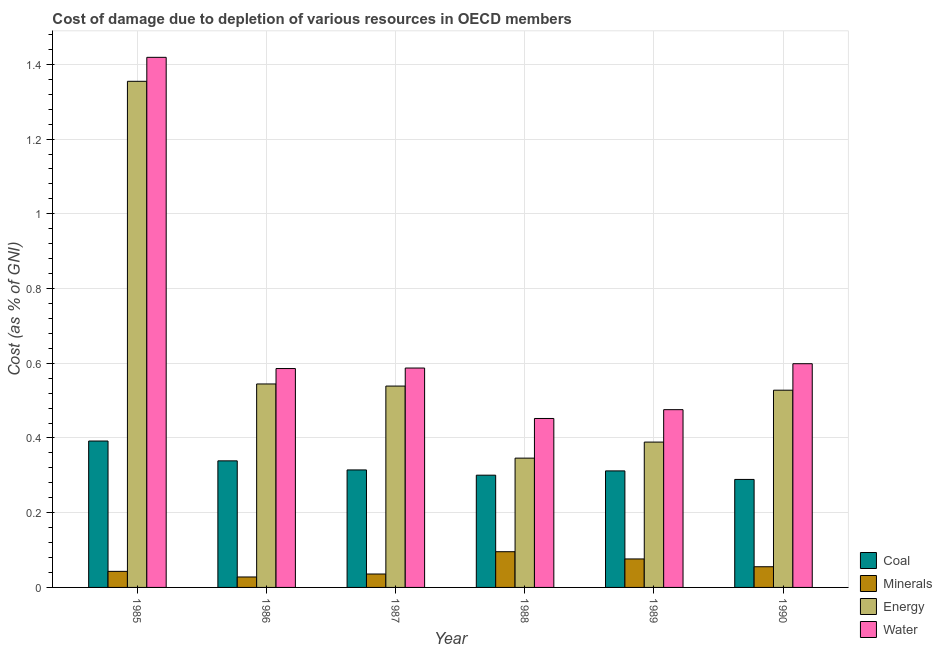How many groups of bars are there?
Offer a very short reply. 6. Are the number of bars per tick equal to the number of legend labels?
Offer a terse response. Yes. How many bars are there on the 4th tick from the right?
Keep it short and to the point. 4. What is the label of the 5th group of bars from the left?
Give a very brief answer. 1989. What is the cost of damage due to depletion of water in 1986?
Give a very brief answer. 0.59. Across all years, what is the maximum cost of damage due to depletion of energy?
Keep it short and to the point. 1.35. Across all years, what is the minimum cost of damage due to depletion of minerals?
Offer a terse response. 0.03. What is the total cost of damage due to depletion of water in the graph?
Your response must be concise. 4.12. What is the difference between the cost of damage due to depletion of minerals in 1985 and that in 1990?
Provide a short and direct response. -0.01. What is the difference between the cost of damage due to depletion of water in 1988 and the cost of damage due to depletion of energy in 1986?
Your answer should be compact. -0.13. What is the average cost of damage due to depletion of coal per year?
Your response must be concise. 0.32. What is the ratio of the cost of damage due to depletion of coal in 1985 to that in 1987?
Make the answer very short. 1.25. Is the cost of damage due to depletion of water in 1987 less than that in 1990?
Provide a succinct answer. Yes. What is the difference between the highest and the second highest cost of damage due to depletion of minerals?
Make the answer very short. 0.02. What is the difference between the highest and the lowest cost of damage due to depletion of water?
Provide a succinct answer. 0.97. In how many years, is the cost of damage due to depletion of minerals greater than the average cost of damage due to depletion of minerals taken over all years?
Provide a short and direct response. 2. Is it the case that in every year, the sum of the cost of damage due to depletion of water and cost of damage due to depletion of minerals is greater than the sum of cost of damage due to depletion of coal and cost of damage due to depletion of energy?
Ensure brevity in your answer.  Yes. What does the 3rd bar from the left in 1987 represents?
Offer a very short reply. Energy. What does the 3rd bar from the right in 1989 represents?
Provide a short and direct response. Minerals. Is it the case that in every year, the sum of the cost of damage due to depletion of coal and cost of damage due to depletion of minerals is greater than the cost of damage due to depletion of energy?
Provide a succinct answer. No. How many bars are there?
Give a very brief answer. 24. Are all the bars in the graph horizontal?
Offer a terse response. No. Does the graph contain any zero values?
Your response must be concise. No. How many legend labels are there?
Offer a terse response. 4. How are the legend labels stacked?
Offer a very short reply. Vertical. What is the title of the graph?
Ensure brevity in your answer.  Cost of damage due to depletion of various resources in OECD members . Does "SF6 gas" appear as one of the legend labels in the graph?
Offer a very short reply. No. What is the label or title of the X-axis?
Your answer should be very brief. Year. What is the label or title of the Y-axis?
Your response must be concise. Cost (as % of GNI). What is the Cost (as % of GNI) of Coal in 1985?
Your answer should be compact. 0.39. What is the Cost (as % of GNI) in Minerals in 1985?
Your response must be concise. 0.04. What is the Cost (as % of GNI) of Energy in 1985?
Make the answer very short. 1.35. What is the Cost (as % of GNI) in Water in 1985?
Give a very brief answer. 1.42. What is the Cost (as % of GNI) of Coal in 1986?
Ensure brevity in your answer.  0.34. What is the Cost (as % of GNI) in Minerals in 1986?
Offer a very short reply. 0.03. What is the Cost (as % of GNI) in Energy in 1986?
Your answer should be compact. 0.54. What is the Cost (as % of GNI) of Water in 1986?
Ensure brevity in your answer.  0.59. What is the Cost (as % of GNI) of Coal in 1987?
Provide a succinct answer. 0.31. What is the Cost (as % of GNI) of Minerals in 1987?
Your answer should be compact. 0.04. What is the Cost (as % of GNI) in Energy in 1987?
Give a very brief answer. 0.54. What is the Cost (as % of GNI) of Water in 1987?
Ensure brevity in your answer.  0.59. What is the Cost (as % of GNI) in Coal in 1988?
Your answer should be very brief. 0.3. What is the Cost (as % of GNI) in Minerals in 1988?
Offer a very short reply. 0.1. What is the Cost (as % of GNI) in Energy in 1988?
Make the answer very short. 0.35. What is the Cost (as % of GNI) in Water in 1988?
Make the answer very short. 0.45. What is the Cost (as % of GNI) in Coal in 1989?
Your answer should be compact. 0.31. What is the Cost (as % of GNI) in Minerals in 1989?
Provide a short and direct response. 0.08. What is the Cost (as % of GNI) of Energy in 1989?
Provide a succinct answer. 0.39. What is the Cost (as % of GNI) in Water in 1989?
Ensure brevity in your answer.  0.48. What is the Cost (as % of GNI) in Coal in 1990?
Provide a short and direct response. 0.29. What is the Cost (as % of GNI) of Minerals in 1990?
Offer a terse response. 0.06. What is the Cost (as % of GNI) of Energy in 1990?
Your answer should be very brief. 0.53. What is the Cost (as % of GNI) in Water in 1990?
Offer a very short reply. 0.6. Across all years, what is the maximum Cost (as % of GNI) in Coal?
Provide a succinct answer. 0.39. Across all years, what is the maximum Cost (as % of GNI) of Minerals?
Offer a very short reply. 0.1. Across all years, what is the maximum Cost (as % of GNI) in Energy?
Your answer should be very brief. 1.35. Across all years, what is the maximum Cost (as % of GNI) in Water?
Provide a succinct answer. 1.42. Across all years, what is the minimum Cost (as % of GNI) of Coal?
Your answer should be compact. 0.29. Across all years, what is the minimum Cost (as % of GNI) in Minerals?
Offer a very short reply. 0.03. Across all years, what is the minimum Cost (as % of GNI) of Energy?
Ensure brevity in your answer.  0.35. Across all years, what is the minimum Cost (as % of GNI) of Water?
Keep it short and to the point. 0.45. What is the total Cost (as % of GNI) in Coal in the graph?
Give a very brief answer. 1.95. What is the total Cost (as % of GNI) of Minerals in the graph?
Ensure brevity in your answer.  0.33. What is the total Cost (as % of GNI) of Energy in the graph?
Provide a short and direct response. 3.7. What is the total Cost (as % of GNI) of Water in the graph?
Provide a succinct answer. 4.12. What is the difference between the Cost (as % of GNI) in Coal in 1985 and that in 1986?
Give a very brief answer. 0.05. What is the difference between the Cost (as % of GNI) of Minerals in 1985 and that in 1986?
Ensure brevity in your answer.  0.01. What is the difference between the Cost (as % of GNI) of Energy in 1985 and that in 1986?
Give a very brief answer. 0.81. What is the difference between the Cost (as % of GNI) in Water in 1985 and that in 1986?
Offer a very short reply. 0.83. What is the difference between the Cost (as % of GNI) in Coal in 1985 and that in 1987?
Offer a very short reply. 0.08. What is the difference between the Cost (as % of GNI) of Minerals in 1985 and that in 1987?
Your answer should be very brief. 0.01. What is the difference between the Cost (as % of GNI) in Energy in 1985 and that in 1987?
Provide a succinct answer. 0.82. What is the difference between the Cost (as % of GNI) in Water in 1985 and that in 1987?
Give a very brief answer. 0.83. What is the difference between the Cost (as % of GNI) in Coal in 1985 and that in 1988?
Ensure brevity in your answer.  0.09. What is the difference between the Cost (as % of GNI) of Minerals in 1985 and that in 1988?
Offer a very short reply. -0.05. What is the difference between the Cost (as % of GNI) of Energy in 1985 and that in 1988?
Your answer should be compact. 1.01. What is the difference between the Cost (as % of GNI) of Water in 1985 and that in 1988?
Make the answer very short. 0.97. What is the difference between the Cost (as % of GNI) in Minerals in 1985 and that in 1989?
Offer a very short reply. -0.03. What is the difference between the Cost (as % of GNI) of Energy in 1985 and that in 1989?
Give a very brief answer. 0.97. What is the difference between the Cost (as % of GNI) in Water in 1985 and that in 1989?
Offer a very short reply. 0.94. What is the difference between the Cost (as % of GNI) of Coal in 1985 and that in 1990?
Your response must be concise. 0.1. What is the difference between the Cost (as % of GNI) of Minerals in 1985 and that in 1990?
Provide a short and direct response. -0.01. What is the difference between the Cost (as % of GNI) in Energy in 1985 and that in 1990?
Ensure brevity in your answer.  0.83. What is the difference between the Cost (as % of GNI) of Water in 1985 and that in 1990?
Ensure brevity in your answer.  0.82. What is the difference between the Cost (as % of GNI) of Coal in 1986 and that in 1987?
Your response must be concise. 0.02. What is the difference between the Cost (as % of GNI) of Minerals in 1986 and that in 1987?
Your response must be concise. -0.01. What is the difference between the Cost (as % of GNI) of Energy in 1986 and that in 1987?
Give a very brief answer. 0.01. What is the difference between the Cost (as % of GNI) of Water in 1986 and that in 1987?
Give a very brief answer. -0. What is the difference between the Cost (as % of GNI) in Coal in 1986 and that in 1988?
Provide a short and direct response. 0.04. What is the difference between the Cost (as % of GNI) of Minerals in 1986 and that in 1988?
Make the answer very short. -0.07. What is the difference between the Cost (as % of GNI) of Energy in 1986 and that in 1988?
Offer a very short reply. 0.2. What is the difference between the Cost (as % of GNI) in Water in 1986 and that in 1988?
Provide a short and direct response. 0.13. What is the difference between the Cost (as % of GNI) in Coal in 1986 and that in 1989?
Provide a succinct answer. 0.03. What is the difference between the Cost (as % of GNI) of Minerals in 1986 and that in 1989?
Your response must be concise. -0.05. What is the difference between the Cost (as % of GNI) in Energy in 1986 and that in 1989?
Provide a succinct answer. 0.16. What is the difference between the Cost (as % of GNI) in Water in 1986 and that in 1989?
Offer a terse response. 0.11. What is the difference between the Cost (as % of GNI) of Coal in 1986 and that in 1990?
Your answer should be compact. 0.05. What is the difference between the Cost (as % of GNI) of Minerals in 1986 and that in 1990?
Ensure brevity in your answer.  -0.03. What is the difference between the Cost (as % of GNI) of Energy in 1986 and that in 1990?
Your answer should be very brief. 0.02. What is the difference between the Cost (as % of GNI) of Water in 1986 and that in 1990?
Your response must be concise. -0.01. What is the difference between the Cost (as % of GNI) in Coal in 1987 and that in 1988?
Your response must be concise. 0.01. What is the difference between the Cost (as % of GNI) of Minerals in 1987 and that in 1988?
Provide a succinct answer. -0.06. What is the difference between the Cost (as % of GNI) of Energy in 1987 and that in 1988?
Your answer should be compact. 0.19. What is the difference between the Cost (as % of GNI) in Water in 1987 and that in 1988?
Your answer should be compact. 0.14. What is the difference between the Cost (as % of GNI) of Coal in 1987 and that in 1989?
Provide a succinct answer. 0. What is the difference between the Cost (as % of GNI) of Minerals in 1987 and that in 1989?
Keep it short and to the point. -0.04. What is the difference between the Cost (as % of GNI) in Energy in 1987 and that in 1989?
Make the answer very short. 0.15. What is the difference between the Cost (as % of GNI) of Water in 1987 and that in 1989?
Ensure brevity in your answer.  0.11. What is the difference between the Cost (as % of GNI) in Coal in 1987 and that in 1990?
Ensure brevity in your answer.  0.03. What is the difference between the Cost (as % of GNI) of Minerals in 1987 and that in 1990?
Provide a succinct answer. -0.02. What is the difference between the Cost (as % of GNI) of Energy in 1987 and that in 1990?
Your answer should be very brief. 0.01. What is the difference between the Cost (as % of GNI) of Water in 1987 and that in 1990?
Your response must be concise. -0.01. What is the difference between the Cost (as % of GNI) in Coal in 1988 and that in 1989?
Your answer should be compact. -0.01. What is the difference between the Cost (as % of GNI) of Minerals in 1988 and that in 1989?
Your answer should be very brief. 0.02. What is the difference between the Cost (as % of GNI) in Energy in 1988 and that in 1989?
Keep it short and to the point. -0.04. What is the difference between the Cost (as % of GNI) in Water in 1988 and that in 1989?
Make the answer very short. -0.02. What is the difference between the Cost (as % of GNI) of Coal in 1988 and that in 1990?
Make the answer very short. 0.01. What is the difference between the Cost (as % of GNI) of Minerals in 1988 and that in 1990?
Your answer should be very brief. 0.04. What is the difference between the Cost (as % of GNI) in Energy in 1988 and that in 1990?
Provide a succinct answer. -0.18. What is the difference between the Cost (as % of GNI) of Water in 1988 and that in 1990?
Keep it short and to the point. -0.15. What is the difference between the Cost (as % of GNI) of Coal in 1989 and that in 1990?
Make the answer very short. 0.02. What is the difference between the Cost (as % of GNI) in Minerals in 1989 and that in 1990?
Ensure brevity in your answer.  0.02. What is the difference between the Cost (as % of GNI) in Energy in 1989 and that in 1990?
Keep it short and to the point. -0.14. What is the difference between the Cost (as % of GNI) in Water in 1989 and that in 1990?
Offer a terse response. -0.12. What is the difference between the Cost (as % of GNI) in Coal in 1985 and the Cost (as % of GNI) in Minerals in 1986?
Give a very brief answer. 0.36. What is the difference between the Cost (as % of GNI) in Coal in 1985 and the Cost (as % of GNI) in Energy in 1986?
Provide a short and direct response. -0.15. What is the difference between the Cost (as % of GNI) in Coal in 1985 and the Cost (as % of GNI) in Water in 1986?
Offer a terse response. -0.19. What is the difference between the Cost (as % of GNI) in Minerals in 1985 and the Cost (as % of GNI) in Energy in 1986?
Provide a succinct answer. -0.5. What is the difference between the Cost (as % of GNI) of Minerals in 1985 and the Cost (as % of GNI) of Water in 1986?
Make the answer very short. -0.54. What is the difference between the Cost (as % of GNI) in Energy in 1985 and the Cost (as % of GNI) in Water in 1986?
Keep it short and to the point. 0.77. What is the difference between the Cost (as % of GNI) in Coal in 1985 and the Cost (as % of GNI) in Minerals in 1987?
Offer a terse response. 0.36. What is the difference between the Cost (as % of GNI) in Coal in 1985 and the Cost (as % of GNI) in Energy in 1987?
Provide a succinct answer. -0.15. What is the difference between the Cost (as % of GNI) in Coal in 1985 and the Cost (as % of GNI) in Water in 1987?
Provide a short and direct response. -0.2. What is the difference between the Cost (as % of GNI) in Minerals in 1985 and the Cost (as % of GNI) in Energy in 1987?
Provide a short and direct response. -0.5. What is the difference between the Cost (as % of GNI) of Minerals in 1985 and the Cost (as % of GNI) of Water in 1987?
Provide a short and direct response. -0.54. What is the difference between the Cost (as % of GNI) in Energy in 1985 and the Cost (as % of GNI) in Water in 1987?
Offer a terse response. 0.77. What is the difference between the Cost (as % of GNI) of Coal in 1985 and the Cost (as % of GNI) of Minerals in 1988?
Your answer should be very brief. 0.3. What is the difference between the Cost (as % of GNI) in Coal in 1985 and the Cost (as % of GNI) in Energy in 1988?
Provide a succinct answer. 0.05. What is the difference between the Cost (as % of GNI) in Coal in 1985 and the Cost (as % of GNI) in Water in 1988?
Offer a terse response. -0.06. What is the difference between the Cost (as % of GNI) in Minerals in 1985 and the Cost (as % of GNI) in Energy in 1988?
Your response must be concise. -0.3. What is the difference between the Cost (as % of GNI) in Minerals in 1985 and the Cost (as % of GNI) in Water in 1988?
Your answer should be compact. -0.41. What is the difference between the Cost (as % of GNI) in Energy in 1985 and the Cost (as % of GNI) in Water in 1988?
Offer a terse response. 0.9. What is the difference between the Cost (as % of GNI) in Coal in 1985 and the Cost (as % of GNI) in Minerals in 1989?
Provide a short and direct response. 0.32. What is the difference between the Cost (as % of GNI) in Coal in 1985 and the Cost (as % of GNI) in Energy in 1989?
Provide a short and direct response. 0. What is the difference between the Cost (as % of GNI) in Coal in 1985 and the Cost (as % of GNI) in Water in 1989?
Make the answer very short. -0.08. What is the difference between the Cost (as % of GNI) in Minerals in 1985 and the Cost (as % of GNI) in Energy in 1989?
Keep it short and to the point. -0.35. What is the difference between the Cost (as % of GNI) of Minerals in 1985 and the Cost (as % of GNI) of Water in 1989?
Give a very brief answer. -0.43. What is the difference between the Cost (as % of GNI) in Energy in 1985 and the Cost (as % of GNI) in Water in 1989?
Offer a terse response. 0.88. What is the difference between the Cost (as % of GNI) in Coal in 1985 and the Cost (as % of GNI) in Minerals in 1990?
Offer a very short reply. 0.34. What is the difference between the Cost (as % of GNI) of Coal in 1985 and the Cost (as % of GNI) of Energy in 1990?
Your response must be concise. -0.14. What is the difference between the Cost (as % of GNI) in Coal in 1985 and the Cost (as % of GNI) in Water in 1990?
Give a very brief answer. -0.21. What is the difference between the Cost (as % of GNI) in Minerals in 1985 and the Cost (as % of GNI) in Energy in 1990?
Offer a terse response. -0.48. What is the difference between the Cost (as % of GNI) in Minerals in 1985 and the Cost (as % of GNI) in Water in 1990?
Keep it short and to the point. -0.56. What is the difference between the Cost (as % of GNI) of Energy in 1985 and the Cost (as % of GNI) of Water in 1990?
Your answer should be compact. 0.76. What is the difference between the Cost (as % of GNI) in Coal in 1986 and the Cost (as % of GNI) in Minerals in 1987?
Offer a terse response. 0.3. What is the difference between the Cost (as % of GNI) of Coal in 1986 and the Cost (as % of GNI) of Energy in 1987?
Give a very brief answer. -0.2. What is the difference between the Cost (as % of GNI) in Coal in 1986 and the Cost (as % of GNI) in Water in 1987?
Your answer should be very brief. -0.25. What is the difference between the Cost (as % of GNI) of Minerals in 1986 and the Cost (as % of GNI) of Energy in 1987?
Ensure brevity in your answer.  -0.51. What is the difference between the Cost (as % of GNI) of Minerals in 1986 and the Cost (as % of GNI) of Water in 1987?
Your answer should be very brief. -0.56. What is the difference between the Cost (as % of GNI) in Energy in 1986 and the Cost (as % of GNI) in Water in 1987?
Provide a short and direct response. -0.04. What is the difference between the Cost (as % of GNI) in Coal in 1986 and the Cost (as % of GNI) in Minerals in 1988?
Ensure brevity in your answer.  0.24. What is the difference between the Cost (as % of GNI) of Coal in 1986 and the Cost (as % of GNI) of Energy in 1988?
Offer a very short reply. -0.01. What is the difference between the Cost (as % of GNI) in Coal in 1986 and the Cost (as % of GNI) in Water in 1988?
Offer a very short reply. -0.11. What is the difference between the Cost (as % of GNI) in Minerals in 1986 and the Cost (as % of GNI) in Energy in 1988?
Ensure brevity in your answer.  -0.32. What is the difference between the Cost (as % of GNI) of Minerals in 1986 and the Cost (as % of GNI) of Water in 1988?
Your answer should be very brief. -0.42. What is the difference between the Cost (as % of GNI) in Energy in 1986 and the Cost (as % of GNI) in Water in 1988?
Your answer should be very brief. 0.09. What is the difference between the Cost (as % of GNI) in Coal in 1986 and the Cost (as % of GNI) in Minerals in 1989?
Your answer should be compact. 0.26. What is the difference between the Cost (as % of GNI) of Coal in 1986 and the Cost (as % of GNI) of Energy in 1989?
Offer a very short reply. -0.05. What is the difference between the Cost (as % of GNI) in Coal in 1986 and the Cost (as % of GNI) in Water in 1989?
Make the answer very short. -0.14. What is the difference between the Cost (as % of GNI) in Minerals in 1986 and the Cost (as % of GNI) in Energy in 1989?
Give a very brief answer. -0.36. What is the difference between the Cost (as % of GNI) in Minerals in 1986 and the Cost (as % of GNI) in Water in 1989?
Offer a very short reply. -0.45. What is the difference between the Cost (as % of GNI) in Energy in 1986 and the Cost (as % of GNI) in Water in 1989?
Give a very brief answer. 0.07. What is the difference between the Cost (as % of GNI) in Coal in 1986 and the Cost (as % of GNI) in Minerals in 1990?
Offer a very short reply. 0.28. What is the difference between the Cost (as % of GNI) in Coal in 1986 and the Cost (as % of GNI) in Energy in 1990?
Keep it short and to the point. -0.19. What is the difference between the Cost (as % of GNI) of Coal in 1986 and the Cost (as % of GNI) of Water in 1990?
Your response must be concise. -0.26. What is the difference between the Cost (as % of GNI) in Minerals in 1986 and the Cost (as % of GNI) in Energy in 1990?
Ensure brevity in your answer.  -0.5. What is the difference between the Cost (as % of GNI) in Minerals in 1986 and the Cost (as % of GNI) in Water in 1990?
Provide a succinct answer. -0.57. What is the difference between the Cost (as % of GNI) of Energy in 1986 and the Cost (as % of GNI) of Water in 1990?
Ensure brevity in your answer.  -0.05. What is the difference between the Cost (as % of GNI) in Coal in 1987 and the Cost (as % of GNI) in Minerals in 1988?
Your answer should be very brief. 0.22. What is the difference between the Cost (as % of GNI) in Coal in 1987 and the Cost (as % of GNI) in Energy in 1988?
Offer a terse response. -0.03. What is the difference between the Cost (as % of GNI) in Coal in 1987 and the Cost (as % of GNI) in Water in 1988?
Offer a very short reply. -0.14. What is the difference between the Cost (as % of GNI) of Minerals in 1987 and the Cost (as % of GNI) of Energy in 1988?
Your response must be concise. -0.31. What is the difference between the Cost (as % of GNI) of Minerals in 1987 and the Cost (as % of GNI) of Water in 1988?
Provide a short and direct response. -0.42. What is the difference between the Cost (as % of GNI) of Energy in 1987 and the Cost (as % of GNI) of Water in 1988?
Ensure brevity in your answer.  0.09. What is the difference between the Cost (as % of GNI) in Coal in 1987 and the Cost (as % of GNI) in Minerals in 1989?
Offer a very short reply. 0.24. What is the difference between the Cost (as % of GNI) in Coal in 1987 and the Cost (as % of GNI) in Energy in 1989?
Give a very brief answer. -0.07. What is the difference between the Cost (as % of GNI) of Coal in 1987 and the Cost (as % of GNI) of Water in 1989?
Offer a very short reply. -0.16. What is the difference between the Cost (as % of GNI) of Minerals in 1987 and the Cost (as % of GNI) of Energy in 1989?
Keep it short and to the point. -0.35. What is the difference between the Cost (as % of GNI) in Minerals in 1987 and the Cost (as % of GNI) in Water in 1989?
Offer a terse response. -0.44. What is the difference between the Cost (as % of GNI) in Energy in 1987 and the Cost (as % of GNI) in Water in 1989?
Ensure brevity in your answer.  0.06. What is the difference between the Cost (as % of GNI) of Coal in 1987 and the Cost (as % of GNI) of Minerals in 1990?
Provide a succinct answer. 0.26. What is the difference between the Cost (as % of GNI) of Coal in 1987 and the Cost (as % of GNI) of Energy in 1990?
Make the answer very short. -0.21. What is the difference between the Cost (as % of GNI) of Coal in 1987 and the Cost (as % of GNI) of Water in 1990?
Keep it short and to the point. -0.28. What is the difference between the Cost (as % of GNI) in Minerals in 1987 and the Cost (as % of GNI) in Energy in 1990?
Give a very brief answer. -0.49. What is the difference between the Cost (as % of GNI) of Minerals in 1987 and the Cost (as % of GNI) of Water in 1990?
Your answer should be very brief. -0.56. What is the difference between the Cost (as % of GNI) of Energy in 1987 and the Cost (as % of GNI) of Water in 1990?
Your answer should be compact. -0.06. What is the difference between the Cost (as % of GNI) in Coal in 1988 and the Cost (as % of GNI) in Minerals in 1989?
Offer a terse response. 0.22. What is the difference between the Cost (as % of GNI) of Coal in 1988 and the Cost (as % of GNI) of Energy in 1989?
Provide a succinct answer. -0.09. What is the difference between the Cost (as % of GNI) in Coal in 1988 and the Cost (as % of GNI) in Water in 1989?
Your answer should be compact. -0.18. What is the difference between the Cost (as % of GNI) of Minerals in 1988 and the Cost (as % of GNI) of Energy in 1989?
Provide a succinct answer. -0.29. What is the difference between the Cost (as % of GNI) in Minerals in 1988 and the Cost (as % of GNI) in Water in 1989?
Your response must be concise. -0.38. What is the difference between the Cost (as % of GNI) in Energy in 1988 and the Cost (as % of GNI) in Water in 1989?
Your answer should be compact. -0.13. What is the difference between the Cost (as % of GNI) in Coal in 1988 and the Cost (as % of GNI) in Minerals in 1990?
Ensure brevity in your answer.  0.25. What is the difference between the Cost (as % of GNI) of Coal in 1988 and the Cost (as % of GNI) of Energy in 1990?
Keep it short and to the point. -0.23. What is the difference between the Cost (as % of GNI) of Coal in 1988 and the Cost (as % of GNI) of Water in 1990?
Ensure brevity in your answer.  -0.3. What is the difference between the Cost (as % of GNI) of Minerals in 1988 and the Cost (as % of GNI) of Energy in 1990?
Offer a terse response. -0.43. What is the difference between the Cost (as % of GNI) of Minerals in 1988 and the Cost (as % of GNI) of Water in 1990?
Make the answer very short. -0.5. What is the difference between the Cost (as % of GNI) of Energy in 1988 and the Cost (as % of GNI) of Water in 1990?
Give a very brief answer. -0.25. What is the difference between the Cost (as % of GNI) in Coal in 1989 and the Cost (as % of GNI) in Minerals in 1990?
Your answer should be compact. 0.26. What is the difference between the Cost (as % of GNI) in Coal in 1989 and the Cost (as % of GNI) in Energy in 1990?
Keep it short and to the point. -0.22. What is the difference between the Cost (as % of GNI) in Coal in 1989 and the Cost (as % of GNI) in Water in 1990?
Your answer should be compact. -0.29. What is the difference between the Cost (as % of GNI) in Minerals in 1989 and the Cost (as % of GNI) in Energy in 1990?
Ensure brevity in your answer.  -0.45. What is the difference between the Cost (as % of GNI) in Minerals in 1989 and the Cost (as % of GNI) in Water in 1990?
Your answer should be very brief. -0.52. What is the difference between the Cost (as % of GNI) of Energy in 1989 and the Cost (as % of GNI) of Water in 1990?
Your answer should be compact. -0.21. What is the average Cost (as % of GNI) in Coal per year?
Give a very brief answer. 0.32. What is the average Cost (as % of GNI) in Minerals per year?
Provide a short and direct response. 0.06. What is the average Cost (as % of GNI) of Energy per year?
Provide a succinct answer. 0.62. What is the average Cost (as % of GNI) of Water per year?
Your answer should be very brief. 0.69. In the year 1985, what is the difference between the Cost (as % of GNI) in Coal and Cost (as % of GNI) in Minerals?
Provide a short and direct response. 0.35. In the year 1985, what is the difference between the Cost (as % of GNI) in Coal and Cost (as % of GNI) in Energy?
Your answer should be very brief. -0.96. In the year 1985, what is the difference between the Cost (as % of GNI) in Coal and Cost (as % of GNI) in Water?
Your response must be concise. -1.03. In the year 1985, what is the difference between the Cost (as % of GNI) of Minerals and Cost (as % of GNI) of Energy?
Offer a terse response. -1.31. In the year 1985, what is the difference between the Cost (as % of GNI) in Minerals and Cost (as % of GNI) in Water?
Offer a very short reply. -1.38. In the year 1985, what is the difference between the Cost (as % of GNI) in Energy and Cost (as % of GNI) in Water?
Offer a very short reply. -0.06. In the year 1986, what is the difference between the Cost (as % of GNI) in Coal and Cost (as % of GNI) in Minerals?
Provide a short and direct response. 0.31. In the year 1986, what is the difference between the Cost (as % of GNI) of Coal and Cost (as % of GNI) of Energy?
Make the answer very short. -0.21. In the year 1986, what is the difference between the Cost (as % of GNI) in Coal and Cost (as % of GNI) in Water?
Provide a succinct answer. -0.25. In the year 1986, what is the difference between the Cost (as % of GNI) of Minerals and Cost (as % of GNI) of Energy?
Make the answer very short. -0.52. In the year 1986, what is the difference between the Cost (as % of GNI) in Minerals and Cost (as % of GNI) in Water?
Keep it short and to the point. -0.56. In the year 1986, what is the difference between the Cost (as % of GNI) in Energy and Cost (as % of GNI) in Water?
Ensure brevity in your answer.  -0.04. In the year 1987, what is the difference between the Cost (as % of GNI) in Coal and Cost (as % of GNI) in Minerals?
Provide a succinct answer. 0.28. In the year 1987, what is the difference between the Cost (as % of GNI) of Coal and Cost (as % of GNI) of Energy?
Give a very brief answer. -0.22. In the year 1987, what is the difference between the Cost (as % of GNI) in Coal and Cost (as % of GNI) in Water?
Offer a terse response. -0.27. In the year 1987, what is the difference between the Cost (as % of GNI) of Minerals and Cost (as % of GNI) of Energy?
Your response must be concise. -0.5. In the year 1987, what is the difference between the Cost (as % of GNI) in Minerals and Cost (as % of GNI) in Water?
Your answer should be compact. -0.55. In the year 1987, what is the difference between the Cost (as % of GNI) in Energy and Cost (as % of GNI) in Water?
Provide a short and direct response. -0.05. In the year 1988, what is the difference between the Cost (as % of GNI) in Coal and Cost (as % of GNI) in Minerals?
Your response must be concise. 0.2. In the year 1988, what is the difference between the Cost (as % of GNI) of Coal and Cost (as % of GNI) of Energy?
Your response must be concise. -0.05. In the year 1988, what is the difference between the Cost (as % of GNI) in Coal and Cost (as % of GNI) in Water?
Offer a very short reply. -0.15. In the year 1988, what is the difference between the Cost (as % of GNI) of Minerals and Cost (as % of GNI) of Energy?
Make the answer very short. -0.25. In the year 1988, what is the difference between the Cost (as % of GNI) in Minerals and Cost (as % of GNI) in Water?
Your answer should be very brief. -0.36. In the year 1988, what is the difference between the Cost (as % of GNI) of Energy and Cost (as % of GNI) of Water?
Make the answer very short. -0.11. In the year 1989, what is the difference between the Cost (as % of GNI) of Coal and Cost (as % of GNI) of Minerals?
Provide a short and direct response. 0.24. In the year 1989, what is the difference between the Cost (as % of GNI) of Coal and Cost (as % of GNI) of Energy?
Offer a very short reply. -0.08. In the year 1989, what is the difference between the Cost (as % of GNI) of Coal and Cost (as % of GNI) of Water?
Your answer should be very brief. -0.16. In the year 1989, what is the difference between the Cost (as % of GNI) of Minerals and Cost (as % of GNI) of Energy?
Make the answer very short. -0.31. In the year 1989, what is the difference between the Cost (as % of GNI) of Minerals and Cost (as % of GNI) of Water?
Offer a very short reply. -0.4. In the year 1989, what is the difference between the Cost (as % of GNI) of Energy and Cost (as % of GNI) of Water?
Provide a succinct answer. -0.09. In the year 1990, what is the difference between the Cost (as % of GNI) of Coal and Cost (as % of GNI) of Minerals?
Offer a very short reply. 0.23. In the year 1990, what is the difference between the Cost (as % of GNI) in Coal and Cost (as % of GNI) in Energy?
Ensure brevity in your answer.  -0.24. In the year 1990, what is the difference between the Cost (as % of GNI) in Coal and Cost (as % of GNI) in Water?
Your answer should be compact. -0.31. In the year 1990, what is the difference between the Cost (as % of GNI) in Minerals and Cost (as % of GNI) in Energy?
Provide a succinct answer. -0.47. In the year 1990, what is the difference between the Cost (as % of GNI) of Minerals and Cost (as % of GNI) of Water?
Offer a terse response. -0.54. In the year 1990, what is the difference between the Cost (as % of GNI) in Energy and Cost (as % of GNI) in Water?
Provide a short and direct response. -0.07. What is the ratio of the Cost (as % of GNI) in Coal in 1985 to that in 1986?
Provide a succinct answer. 1.16. What is the ratio of the Cost (as % of GNI) of Minerals in 1985 to that in 1986?
Your answer should be compact. 1.54. What is the ratio of the Cost (as % of GNI) in Energy in 1985 to that in 1986?
Provide a succinct answer. 2.49. What is the ratio of the Cost (as % of GNI) of Water in 1985 to that in 1986?
Ensure brevity in your answer.  2.42. What is the ratio of the Cost (as % of GNI) in Coal in 1985 to that in 1987?
Your answer should be compact. 1.25. What is the ratio of the Cost (as % of GNI) in Minerals in 1985 to that in 1987?
Your response must be concise. 1.2. What is the ratio of the Cost (as % of GNI) of Energy in 1985 to that in 1987?
Your response must be concise. 2.51. What is the ratio of the Cost (as % of GNI) of Water in 1985 to that in 1987?
Make the answer very short. 2.42. What is the ratio of the Cost (as % of GNI) in Coal in 1985 to that in 1988?
Your answer should be very brief. 1.3. What is the ratio of the Cost (as % of GNI) in Minerals in 1985 to that in 1988?
Provide a succinct answer. 0.45. What is the ratio of the Cost (as % of GNI) in Energy in 1985 to that in 1988?
Give a very brief answer. 3.91. What is the ratio of the Cost (as % of GNI) of Water in 1985 to that in 1988?
Make the answer very short. 3.14. What is the ratio of the Cost (as % of GNI) in Coal in 1985 to that in 1989?
Offer a very short reply. 1.26. What is the ratio of the Cost (as % of GNI) of Minerals in 1985 to that in 1989?
Offer a very short reply. 0.56. What is the ratio of the Cost (as % of GNI) of Energy in 1985 to that in 1989?
Give a very brief answer. 3.48. What is the ratio of the Cost (as % of GNI) in Water in 1985 to that in 1989?
Offer a terse response. 2.98. What is the ratio of the Cost (as % of GNI) in Coal in 1985 to that in 1990?
Make the answer very short. 1.36. What is the ratio of the Cost (as % of GNI) in Minerals in 1985 to that in 1990?
Ensure brevity in your answer.  0.78. What is the ratio of the Cost (as % of GNI) of Energy in 1985 to that in 1990?
Your response must be concise. 2.57. What is the ratio of the Cost (as % of GNI) in Water in 1985 to that in 1990?
Your answer should be compact. 2.37. What is the ratio of the Cost (as % of GNI) in Coal in 1986 to that in 1987?
Provide a succinct answer. 1.08. What is the ratio of the Cost (as % of GNI) of Minerals in 1986 to that in 1987?
Your answer should be very brief. 0.78. What is the ratio of the Cost (as % of GNI) in Energy in 1986 to that in 1987?
Your answer should be very brief. 1.01. What is the ratio of the Cost (as % of GNI) of Coal in 1986 to that in 1988?
Offer a very short reply. 1.13. What is the ratio of the Cost (as % of GNI) in Minerals in 1986 to that in 1988?
Offer a terse response. 0.29. What is the ratio of the Cost (as % of GNI) of Energy in 1986 to that in 1988?
Your answer should be very brief. 1.57. What is the ratio of the Cost (as % of GNI) in Water in 1986 to that in 1988?
Your response must be concise. 1.3. What is the ratio of the Cost (as % of GNI) of Coal in 1986 to that in 1989?
Ensure brevity in your answer.  1.09. What is the ratio of the Cost (as % of GNI) in Minerals in 1986 to that in 1989?
Your answer should be very brief. 0.37. What is the ratio of the Cost (as % of GNI) of Energy in 1986 to that in 1989?
Provide a short and direct response. 1.4. What is the ratio of the Cost (as % of GNI) of Water in 1986 to that in 1989?
Keep it short and to the point. 1.23. What is the ratio of the Cost (as % of GNI) of Coal in 1986 to that in 1990?
Make the answer very short. 1.17. What is the ratio of the Cost (as % of GNI) in Minerals in 1986 to that in 1990?
Keep it short and to the point. 0.51. What is the ratio of the Cost (as % of GNI) in Energy in 1986 to that in 1990?
Offer a very short reply. 1.03. What is the ratio of the Cost (as % of GNI) in Water in 1986 to that in 1990?
Provide a succinct answer. 0.98. What is the ratio of the Cost (as % of GNI) of Coal in 1987 to that in 1988?
Your answer should be compact. 1.05. What is the ratio of the Cost (as % of GNI) in Minerals in 1987 to that in 1988?
Your answer should be very brief. 0.38. What is the ratio of the Cost (as % of GNI) of Energy in 1987 to that in 1988?
Your response must be concise. 1.56. What is the ratio of the Cost (as % of GNI) in Water in 1987 to that in 1988?
Provide a short and direct response. 1.3. What is the ratio of the Cost (as % of GNI) in Coal in 1987 to that in 1989?
Your answer should be compact. 1.01. What is the ratio of the Cost (as % of GNI) of Minerals in 1987 to that in 1989?
Provide a short and direct response. 0.47. What is the ratio of the Cost (as % of GNI) of Energy in 1987 to that in 1989?
Provide a succinct answer. 1.39. What is the ratio of the Cost (as % of GNI) of Water in 1987 to that in 1989?
Provide a succinct answer. 1.23. What is the ratio of the Cost (as % of GNI) in Coal in 1987 to that in 1990?
Make the answer very short. 1.09. What is the ratio of the Cost (as % of GNI) of Minerals in 1987 to that in 1990?
Give a very brief answer. 0.65. What is the ratio of the Cost (as % of GNI) in Energy in 1987 to that in 1990?
Keep it short and to the point. 1.02. What is the ratio of the Cost (as % of GNI) in Water in 1987 to that in 1990?
Your answer should be very brief. 0.98. What is the ratio of the Cost (as % of GNI) of Coal in 1988 to that in 1989?
Give a very brief answer. 0.96. What is the ratio of the Cost (as % of GNI) of Minerals in 1988 to that in 1989?
Offer a very short reply. 1.25. What is the ratio of the Cost (as % of GNI) in Energy in 1988 to that in 1989?
Your response must be concise. 0.89. What is the ratio of the Cost (as % of GNI) of Water in 1988 to that in 1989?
Provide a succinct answer. 0.95. What is the ratio of the Cost (as % of GNI) in Coal in 1988 to that in 1990?
Your answer should be compact. 1.04. What is the ratio of the Cost (as % of GNI) in Minerals in 1988 to that in 1990?
Ensure brevity in your answer.  1.73. What is the ratio of the Cost (as % of GNI) in Energy in 1988 to that in 1990?
Make the answer very short. 0.66. What is the ratio of the Cost (as % of GNI) in Water in 1988 to that in 1990?
Provide a short and direct response. 0.76. What is the ratio of the Cost (as % of GNI) of Coal in 1989 to that in 1990?
Your answer should be very brief. 1.08. What is the ratio of the Cost (as % of GNI) of Minerals in 1989 to that in 1990?
Provide a short and direct response. 1.38. What is the ratio of the Cost (as % of GNI) of Energy in 1989 to that in 1990?
Your response must be concise. 0.74. What is the ratio of the Cost (as % of GNI) in Water in 1989 to that in 1990?
Offer a very short reply. 0.79. What is the difference between the highest and the second highest Cost (as % of GNI) in Coal?
Keep it short and to the point. 0.05. What is the difference between the highest and the second highest Cost (as % of GNI) of Minerals?
Keep it short and to the point. 0.02. What is the difference between the highest and the second highest Cost (as % of GNI) in Energy?
Give a very brief answer. 0.81. What is the difference between the highest and the second highest Cost (as % of GNI) in Water?
Your response must be concise. 0.82. What is the difference between the highest and the lowest Cost (as % of GNI) of Coal?
Make the answer very short. 0.1. What is the difference between the highest and the lowest Cost (as % of GNI) of Minerals?
Your answer should be very brief. 0.07. What is the difference between the highest and the lowest Cost (as % of GNI) of Energy?
Keep it short and to the point. 1.01. What is the difference between the highest and the lowest Cost (as % of GNI) of Water?
Give a very brief answer. 0.97. 